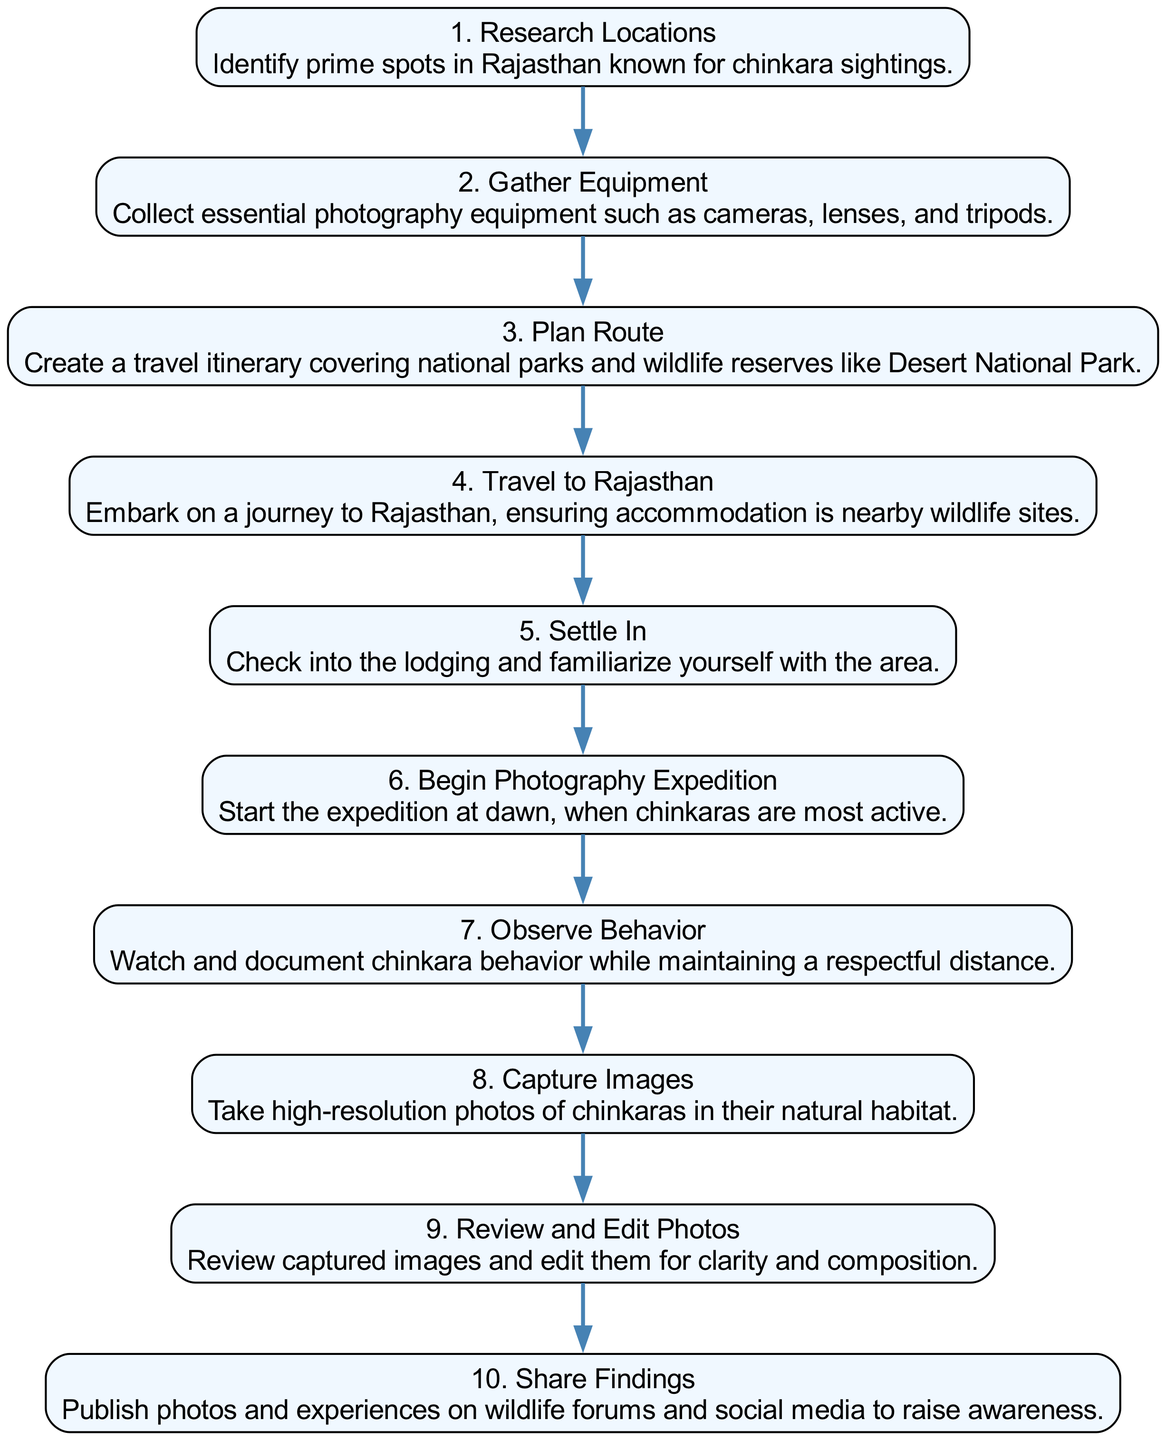What is the first event in the expedition? The first event listed in the diagram is "Research Locations," which identifies prime spots in Rajasthan known for chinkara sightings.
Answer: Research Locations How many events are included in the sequence? By counting the events listed, there are ten events shown in the diagram that represent the stages of the wildlife photography expedition.
Answer: 10 Which event follows "Travel to Rajasthan"? The event that directly follows "Travel to Rajasthan" in the sequence is "Settle In," indicating a transition to checking into lodging after the journey.
Answer: Settle In What is the final step in the wildlife photography expedition? The last event in the series is "Share Findings," which involves publishing photos and experiences on platforms to raise awareness about chinkaras.
Answer: Share Findings What is the relationship between "Observe Behavior" and "Capture Images"? "Observe Behavior" occurs before "Capture Images," indicating that the photography is based on observing chinkaras first before taking pictures.
Answer: Observe Behavior → Capture Images List one type of equipment gathered during the expedition preparation. The event "Gather Equipment" mentions collecting essential photography equipment, including cameras, lenses, and tripods.
Answer: Cameras How long does the expedition start? The event "Begin Photography Expedition" specifies that it starts at dawn, highlighting the time when chinkaras are most active.
Answer: Dawn Which national park is mentioned in the planning phase? The event "Plan Route" refers to creating an itinerary that covers national parks, explicitly mentioning Desert National Park as a significant location for wildlife photography.
Answer: Desert National Park What is the primary focus of this wildlife expedition? The nature of the overall expedition is to document and photograph chinkaras, specifically within their natural habitat in Rajasthan.
Answer: Chinkaras 